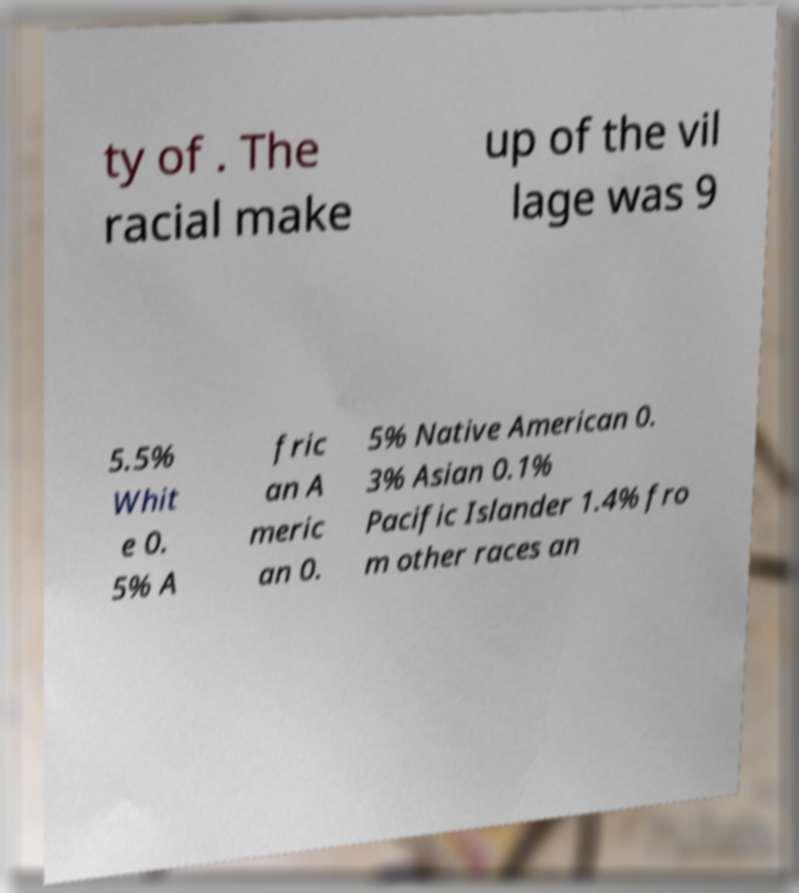Can you read and provide the text displayed in the image?This photo seems to have some interesting text. Can you extract and type it out for me? ty of . The racial make up of the vil lage was 9 5.5% Whit e 0. 5% A fric an A meric an 0. 5% Native American 0. 3% Asian 0.1% Pacific Islander 1.4% fro m other races an 